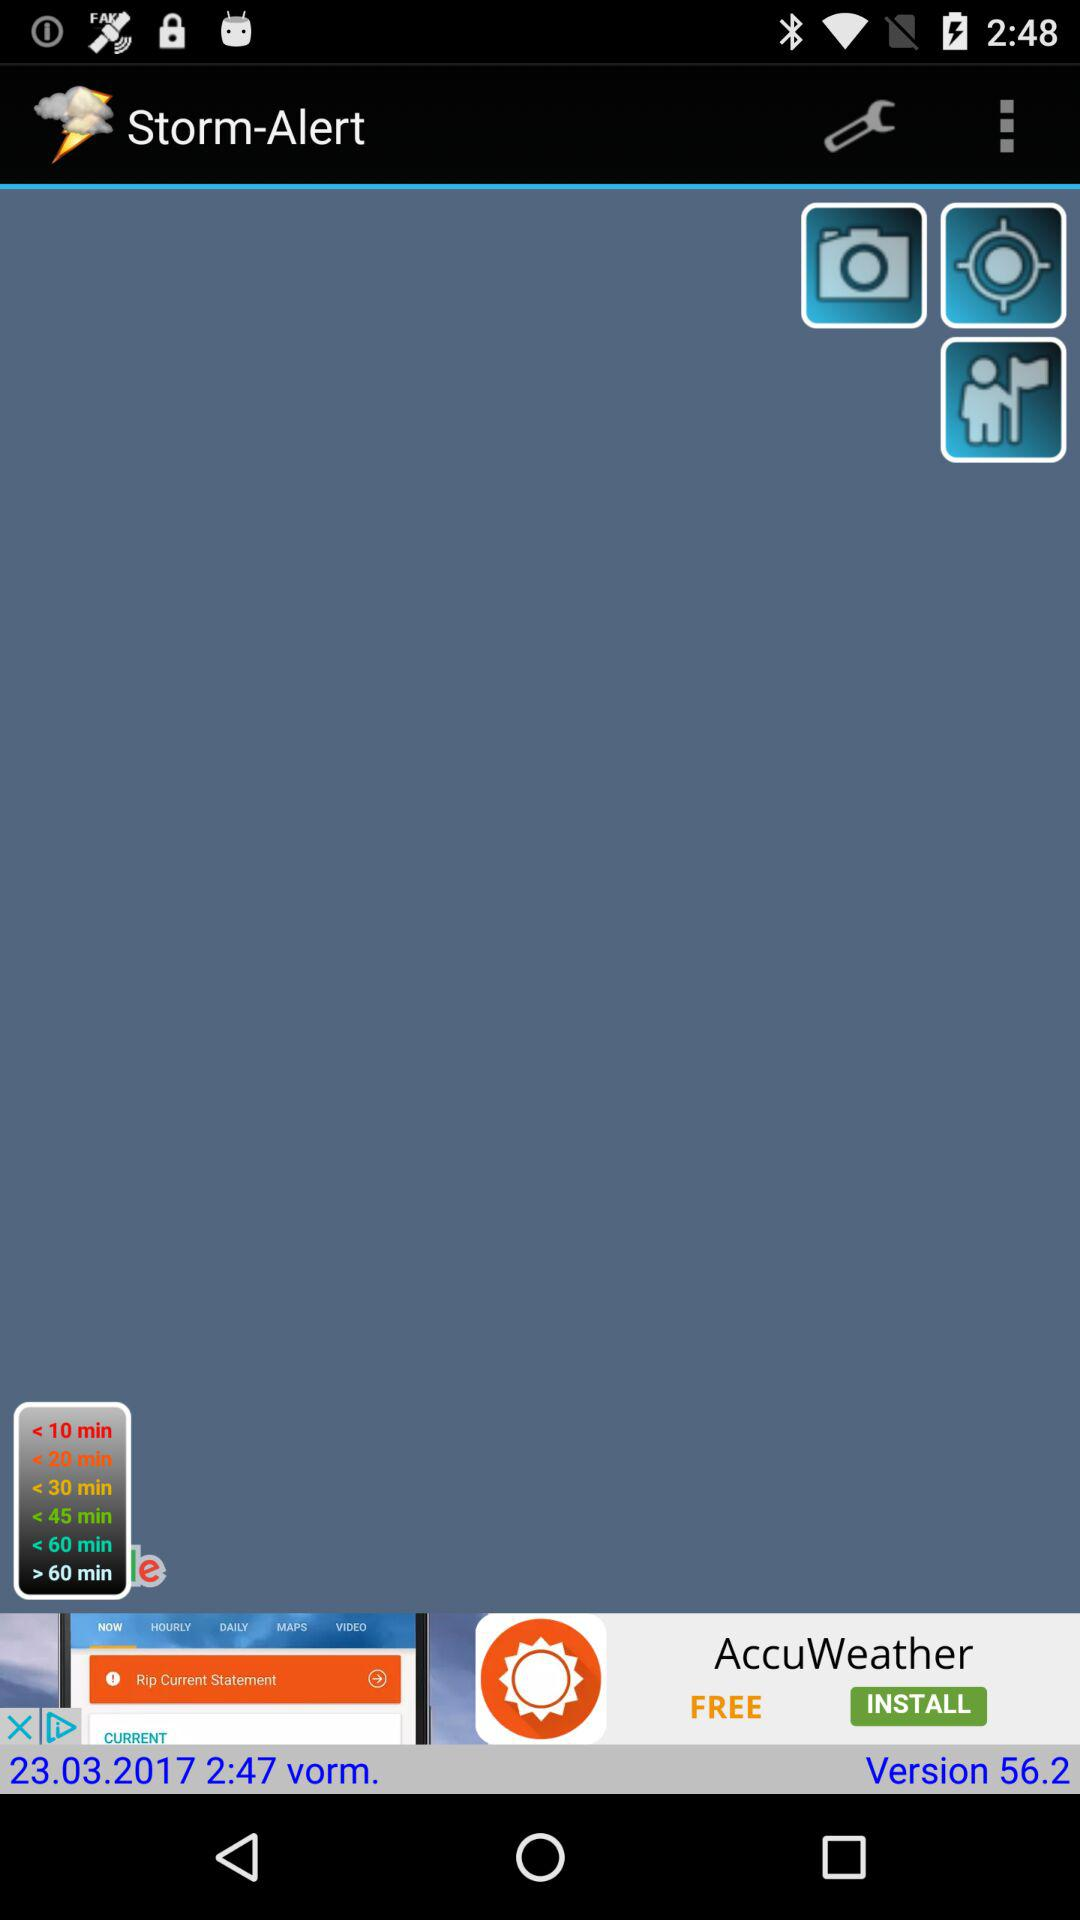What is the application name? The application name is "Storm-Alert". 